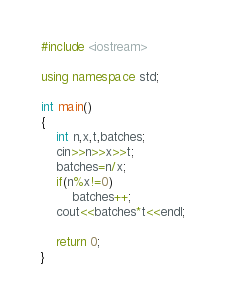Convert code to text. <code><loc_0><loc_0><loc_500><loc_500><_C++_>#include <iostream>

using namespace std;

int main()
{
    int n,x,t,batches;
    cin>>n>>x>>t;
    batches=n/x;
    if(n%x!=0)
        batches++;
    cout<<batches*t<<endl;

    return 0;
}
</code> 